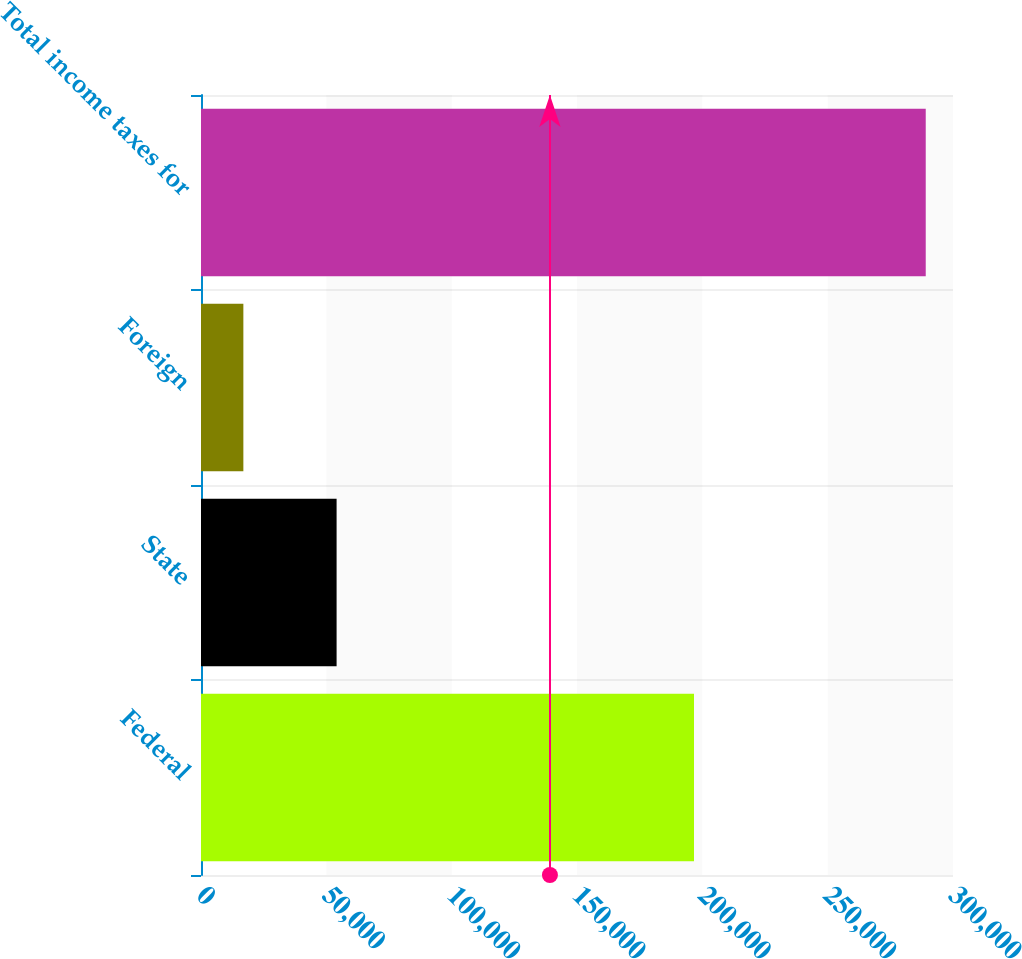Convert chart to OTSL. <chart><loc_0><loc_0><loc_500><loc_500><bar_chart><fcel>Federal<fcel>State<fcel>Foreign<fcel>Total income taxes for<nl><fcel>196676<fcel>54096<fcel>16901<fcel>289124<nl></chart> 